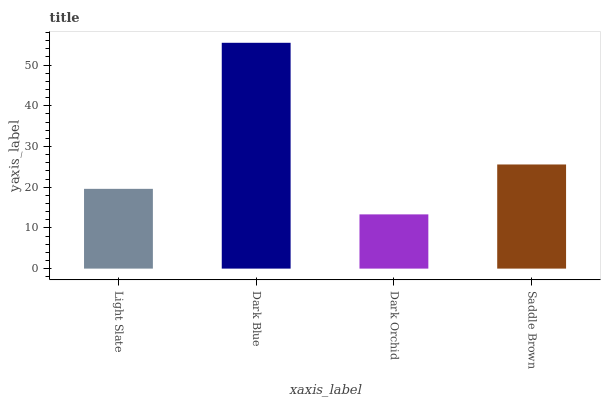Is Dark Orchid the minimum?
Answer yes or no. Yes. Is Dark Blue the maximum?
Answer yes or no. Yes. Is Dark Blue the minimum?
Answer yes or no. No. Is Dark Orchid the maximum?
Answer yes or no. No. Is Dark Blue greater than Dark Orchid?
Answer yes or no. Yes. Is Dark Orchid less than Dark Blue?
Answer yes or no. Yes. Is Dark Orchid greater than Dark Blue?
Answer yes or no. No. Is Dark Blue less than Dark Orchid?
Answer yes or no. No. Is Saddle Brown the high median?
Answer yes or no. Yes. Is Light Slate the low median?
Answer yes or no. Yes. Is Dark Blue the high median?
Answer yes or no. No. Is Saddle Brown the low median?
Answer yes or no. No. 